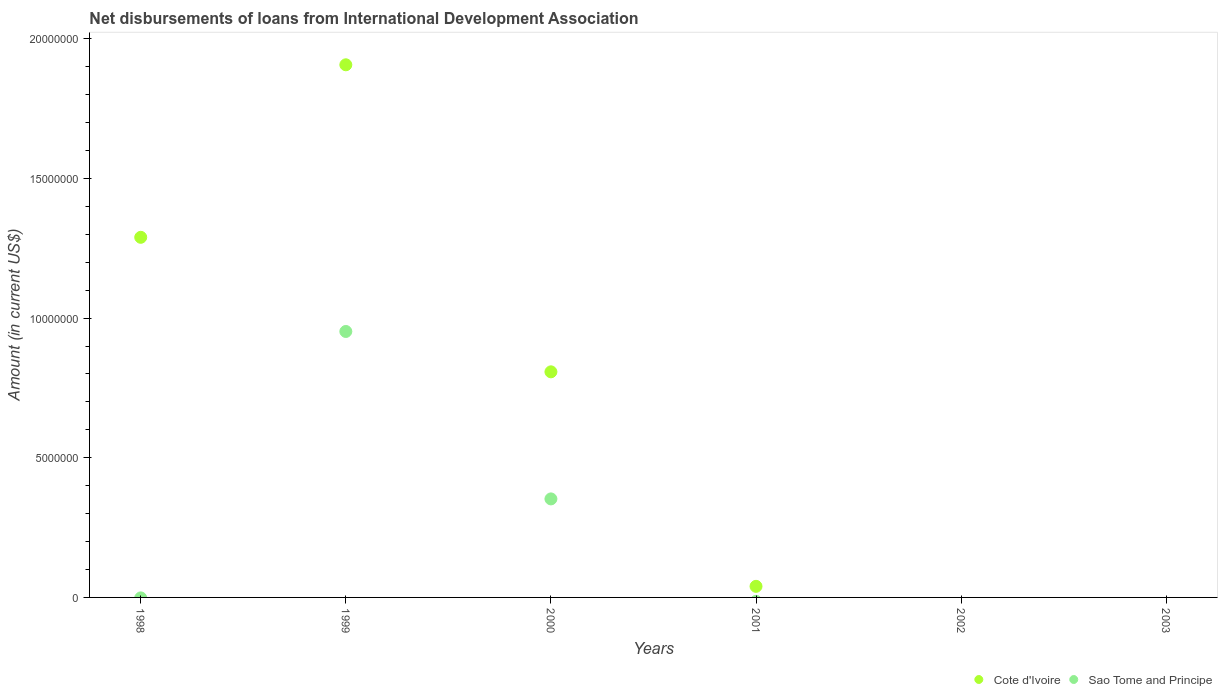What is the amount of loans disbursed in Cote d'Ivoire in 2000?
Your answer should be very brief. 8.08e+06. Across all years, what is the maximum amount of loans disbursed in Sao Tome and Principe?
Your answer should be compact. 9.52e+06. What is the total amount of loans disbursed in Cote d'Ivoire in the graph?
Give a very brief answer. 4.04e+07. What is the difference between the amount of loans disbursed in Cote d'Ivoire in 1998 and that in 2001?
Ensure brevity in your answer.  1.25e+07. What is the difference between the amount of loans disbursed in Cote d'Ivoire in 1998 and the amount of loans disbursed in Sao Tome and Principe in 2001?
Keep it short and to the point. 1.29e+07. What is the average amount of loans disbursed in Cote d'Ivoire per year?
Make the answer very short. 6.74e+06. In the year 2000, what is the difference between the amount of loans disbursed in Cote d'Ivoire and amount of loans disbursed in Sao Tome and Principe?
Provide a succinct answer. 4.55e+06. In how many years, is the amount of loans disbursed in Cote d'Ivoire greater than 18000000 US$?
Your answer should be compact. 1. What is the ratio of the amount of loans disbursed in Cote d'Ivoire in 1999 to that in 2001?
Your answer should be compact. 48.03. Is the difference between the amount of loans disbursed in Cote d'Ivoire in 1999 and 2000 greater than the difference between the amount of loans disbursed in Sao Tome and Principe in 1999 and 2000?
Make the answer very short. Yes. What is the difference between the highest and the second highest amount of loans disbursed in Cote d'Ivoire?
Your answer should be compact. 6.18e+06. What is the difference between the highest and the lowest amount of loans disbursed in Sao Tome and Principe?
Provide a short and direct response. 9.52e+06. In how many years, is the amount of loans disbursed in Sao Tome and Principe greater than the average amount of loans disbursed in Sao Tome and Principe taken over all years?
Ensure brevity in your answer.  2. Does the amount of loans disbursed in Cote d'Ivoire monotonically increase over the years?
Your answer should be compact. No. Is the amount of loans disbursed in Cote d'Ivoire strictly less than the amount of loans disbursed in Sao Tome and Principe over the years?
Provide a succinct answer. No. How many years are there in the graph?
Make the answer very short. 6. What is the difference between two consecutive major ticks on the Y-axis?
Your answer should be very brief. 5.00e+06. Are the values on the major ticks of Y-axis written in scientific E-notation?
Provide a succinct answer. No. Does the graph contain any zero values?
Provide a succinct answer. Yes. How many legend labels are there?
Ensure brevity in your answer.  2. How are the legend labels stacked?
Your answer should be compact. Horizontal. What is the title of the graph?
Make the answer very short. Net disbursements of loans from International Development Association. What is the label or title of the X-axis?
Keep it short and to the point. Years. What is the Amount (in current US$) in Cote d'Ivoire in 1998?
Offer a very short reply. 1.29e+07. What is the Amount (in current US$) in Sao Tome and Principe in 1998?
Your response must be concise. 0. What is the Amount (in current US$) in Cote d'Ivoire in 1999?
Your answer should be compact. 1.91e+07. What is the Amount (in current US$) in Sao Tome and Principe in 1999?
Make the answer very short. 9.52e+06. What is the Amount (in current US$) in Cote d'Ivoire in 2000?
Keep it short and to the point. 8.08e+06. What is the Amount (in current US$) of Sao Tome and Principe in 2000?
Your response must be concise. 3.53e+06. What is the Amount (in current US$) in Cote d'Ivoire in 2001?
Ensure brevity in your answer.  3.97e+05. What is the Amount (in current US$) in Sao Tome and Principe in 2001?
Your answer should be compact. 0. What is the Amount (in current US$) of Sao Tome and Principe in 2002?
Offer a terse response. 0. What is the Amount (in current US$) of Cote d'Ivoire in 2003?
Offer a very short reply. 0. Across all years, what is the maximum Amount (in current US$) in Cote d'Ivoire?
Make the answer very short. 1.91e+07. Across all years, what is the maximum Amount (in current US$) in Sao Tome and Principe?
Your answer should be compact. 9.52e+06. What is the total Amount (in current US$) in Cote d'Ivoire in the graph?
Keep it short and to the point. 4.04e+07. What is the total Amount (in current US$) of Sao Tome and Principe in the graph?
Make the answer very short. 1.30e+07. What is the difference between the Amount (in current US$) of Cote d'Ivoire in 1998 and that in 1999?
Make the answer very short. -6.18e+06. What is the difference between the Amount (in current US$) in Cote d'Ivoire in 1998 and that in 2000?
Your answer should be compact. 4.82e+06. What is the difference between the Amount (in current US$) in Cote d'Ivoire in 1998 and that in 2001?
Give a very brief answer. 1.25e+07. What is the difference between the Amount (in current US$) of Cote d'Ivoire in 1999 and that in 2000?
Ensure brevity in your answer.  1.10e+07. What is the difference between the Amount (in current US$) of Sao Tome and Principe in 1999 and that in 2000?
Make the answer very short. 5.99e+06. What is the difference between the Amount (in current US$) of Cote d'Ivoire in 1999 and that in 2001?
Provide a succinct answer. 1.87e+07. What is the difference between the Amount (in current US$) in Cote d'Ivoire in 2000 and that in 2001?
Provide a succinct answer. 7.68e+06. What is the difference between the Amount (in current US$) of Cote d'Ivoire in 1998 and the Amount (in current US$) of Sao Tome and Principe in 1999?
Keep it short and to the point. 3.37e+06. What is the difference between the Amount (in current US$) in Cote d'Ivoire in 1998 and the Amount (in current US$) in Sao Tome and Principe in 2000?
Give a very brief answer. 9.36e+06. What is the difference between the Amount (in current US$) of Cote d'Ivoire in 1999 and the Amount (in current US$) of Sao Tome and Principe in 2000?
Ensure brevity in your answer.  1.55e+07. What is the average Amount (in current US$) of Cote d'Ivoire per year?
Ensure brevity in your answer.  6.74e+06. What is the average Amount (in current US$) in Sao Tome and Principe per year?
Your answer should be compact. 2.17e+06. In the year 1999, what is the difference between the Amount (in current US$) in Cote d'Ivoire and Amount (in current US$) in Sao Tome and Principe?
Give a very brief answer. 9.55e+06. In the year 2000, what is the difference between the Amount (in current US$) in Cote d'Ivoire and Amount (in current US$) in Sao Tome and Principe?
Provide a succinct answer. 4.55e+06. What is the ratio of the Amount (in current US$) of Cote d'Ivoire in 1998 to that in 1999?
Your answer should be very brief. 0.68. What is the ratio of the Amount (in current US$) of Cote d'Ivoire in 1998 to that in 2000?
Your response must be concise. 1.6. What is the ratio of the Amount (in current US$) in Cote d'Ivoire in 1998 to that in 2001?
Give a very brief answer. 32.47. What is the ratio of the Amount (in current US$) of Cote d'Ivoire in 1999 to that in 2000?
Ensure brevity in your answer.  2.36. What is the ratio of the Amount (in current US$) in Sao Tome and Principe in 1999 to that in 2000?
Give a very brief answer. 2.7. What is the ratio of the Amount (in current US$) in Cote d'Ivoire in 1999 to that in 2001?
Make the answer very short. 48.03. What is the ratio of the Amount (in current US$) in Cote d'Ivoire in 2000 to that in 2001?
Your answer should be compact. 20.34. What is the difference between the highest and the second highest Amount (in current US$) of Cote d'Ivoire?
Offer a very short reply. 6.18e+06. What is the difference between the highest and the lowest Amount (in current US$) in Cote d'Ivoire?
Ensure brevity in your answer.  1.91e+07. What is the difference between the highest and the lowest Amount (in current US$) of Sao Tome and Principe?
Provide a short and direct response. 9.52e+06. 